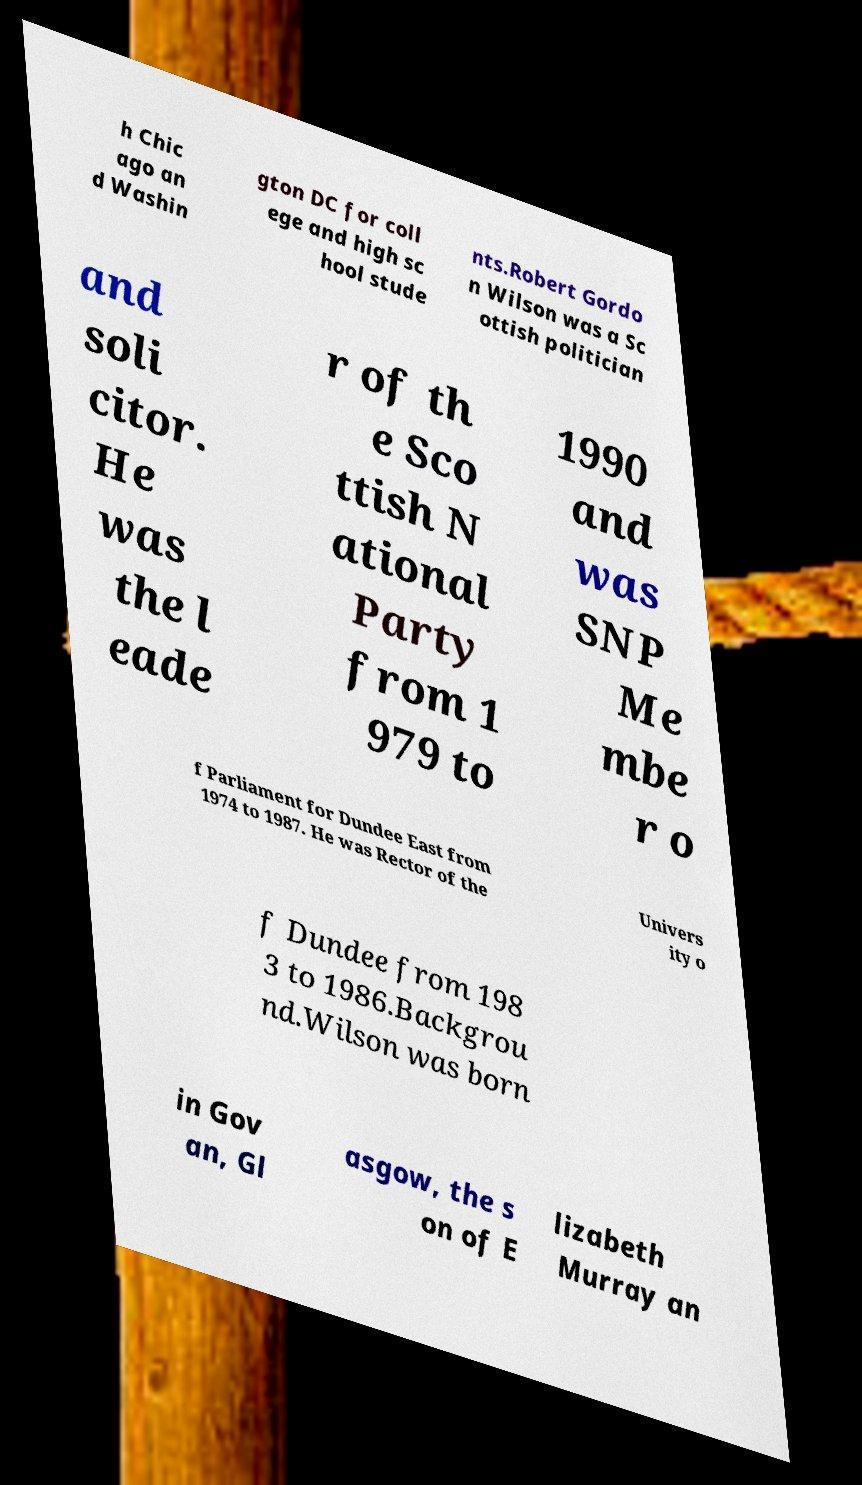I need the written content from this picture converted into text. Can you do that? h Chic ago an d Washin gton DC for coll ege and high sc hool stude nts.Robert Gordo n Wilson was a Sc ottish politician and soli citor. He was the l eade r of th e Sco ttish N ational Party from 1 979 to 1990 and was SNP Me mbe r o f Parliament for Dundee East from 1974 to 1987. He was Rector of the Univers ity o f Dundee from 198 3 to 1986.Backgrou nd.Wilson was born in Gov an, Gl asgow, the s on of E lizabeth Murray an 